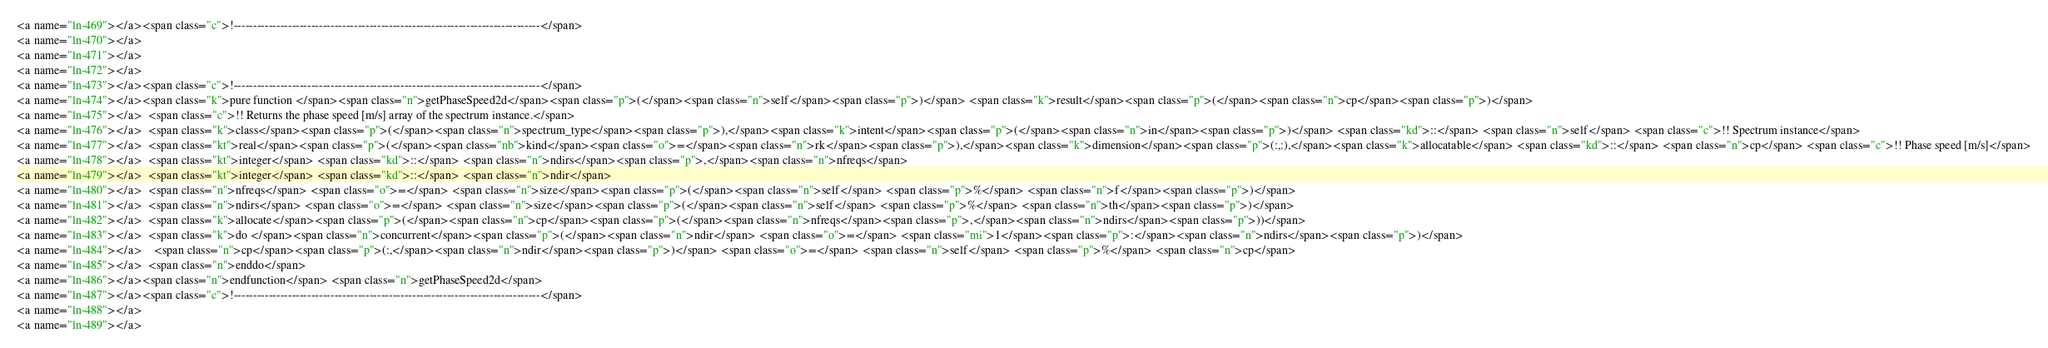Convert code to text. <code><loc_0><loc_0><loc_500><loc_500><_HTML_><a name="ln-469"></a><span class="c">!-------------------------------------------------------------------------------</span>
<a name="ln-470"></a>
<a name="ln-471"></a>
<a name="ln-472"></a>
<a name="ln-473"></a><span class="c">!-------------------------------------------------------------------------------</span>
<a name="ln-474"></a><span class="k">pure function </span><span class="n">getPhaseSpeed2d</span><span class="p">(</span><span class="n">self</span><span class="p">)</span> <span class="k">result</span><span class="p">(</span><span class="n">cp</span><span class="p">)</span>
<a name="ln-475"></a>  <span class="c">!! Returns the phase speed [m/s] array of the spectrum instance.</span>
<a name="ln-476"></a>  <span class="k">class</span><span class="p">(</span><span class="n">spectrum_type</span><span class="p">),</span><span class="k">intent</span><span class="p">(</span><span class="n">in</span><span class="p">)</span> <span class="kd">::</span> <span class="n">self</span> <span class="c">!! Spectrum instance</span>
<a name="ln-477"></a>  <span class="kt">real</span><span class="p">(</span><span class="nb">kind</span><span class="o">=</span><span class="n">rk</span><span class="p">),</span><span class="k">dimension</span><span class="p">(:,:),</span><span class="k">allocatable</span> <span class="kd">::</span> <span class="n">cp</span> <span class="c">!! Phase speed [m/s]</span>
<a name="ln-478"></a>  <span class="kt">integer</span> <span class="kd">::</span> <span class="n">ndirs</span><span class="p">,</span><span class="n">nfreqs</span>
<a name="ln-479"></a>  <span class="kt">integer</span> <span class="kd">::</span> <span class="n">ndir</span>
<a name="ln-480"></a>  <span class="n">nfreqs</span> <span class="o">=</span> <span class="n">size</span><span class="p">(</span><span class="n">self</span> <span class="p">%</span> <span class="n">f</span><span class="p">)</span>
<a name="ln-481"></a>  <span class="n">ndirs</span> <span class="o">=</span> <span class="n">size</span><span class="p">(</span><span class="n">self</span> <span class="p">%</span> <span class="n">th</span><span class="p">)</span>
<a name="ln-482"></a>  <span class="k">allocate</span><span class="p">(</span><span class="n">cp</span><span class="p">(</span><span class="n">nfreqs</span><span class="p">,</span><span class="n">ndirs</span><span class="p">))</span>
<a name="ln-483"></a>  <span class="k">do </span><span class="n">concurrent</span><span class="p">(</span><span class="n">ndir</span> <span class="o">=</span> <span class="mi">1</span><span class="p">:</span><span class="n">ndirs</span><span class="p">)</span>
<a name="ln-484"></a>    <span class="n">cp</span><span class="p">(:,</span><span class="n">ndir</span><span class="p">)</span> <span class="o">=</span> <span class="n">self</span> <span class="p">%</span> <span class="n">cp</span>
<a name="ln-485"></a>  <span class="n">enddo</span>
<a name="ln-486"></a><span class="n">endfunction</span> <span class="n">getPhaseSpeed2d</span>
<a name="ln-487"></a><span class="c">!-------------------------------------------------------------------------------</span>
<a name="ln-488"></a>
<a name="ln-489"></a></code> 